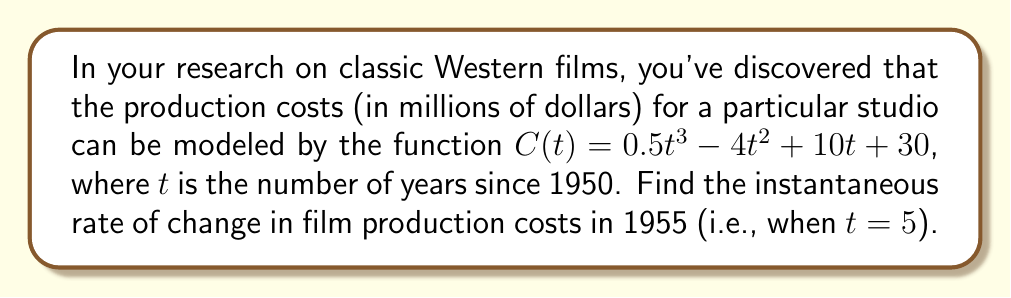Help me with this question. To find the instantaneous rate of change, we need to calculate the derivative of the cost function $C(t)$ and then evaluate it at $t = 5$.

Step 1: Find the derivative of $C(t)$
$$C(t) = 0.5t^3 - 4t^2 + 10t + 30$$
$$C'(t) = 1.5t^2 - 8t + 10$$

Step 2: Evaluate $C'(t)$ at $t = 5$
$$C'(5) = 1.5(5)^2 - 8(5) + 10$$
$$C'(5) = 1.5(25) - 40 + 10$$
$$C'(5) = 37.5 - 40 + 10$$
$$C'(5) = 7.5$$

The instantaneous rate of change is 7.5 million dollars per year in 1955.
Answer: $7.5$ million dollars per year 